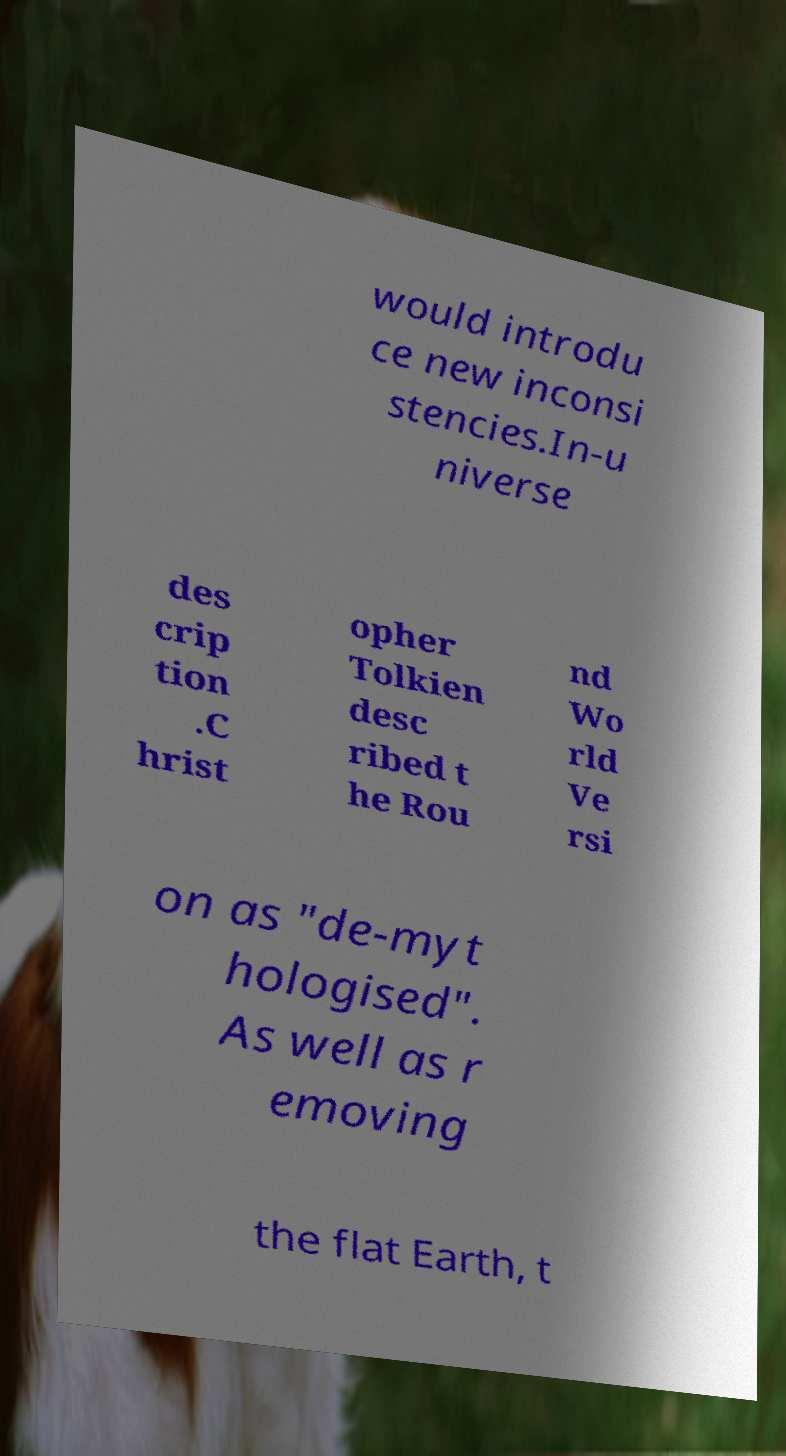What messages or text are displayed in this image? I need them in a readable, typed format. would introdu ce new inconsi stencies.In-u niverse des crip tion .C hrist opher Tolkien desc ribed t he Rou nd Wo rld Ve rsi on as "de-myt hologised". As well as r emoving the flat Earth, t 